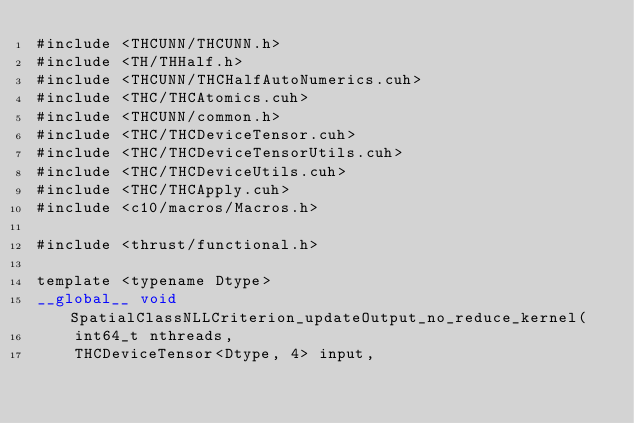Convert code to text. <code><loc_0><loc_0><loc_500><loc_500><_Cuda_>#include <THCUNN/THCUNN.h>
#include <TH/THHalf.h>
#include <THCUNN/THCHalfAutoNumerics.cuh>
#include <THC/THCAtomics.cuh>
#include <THCUNN/common.h>
#include <THC/THCDeviceTensor.cuh>
#include <THC/THCDeviceTensorUtils.cuh>
#include <THC/THCDeviceUtils.cuh>
#include <THC/THCApply.cuh>
#include <c10/macros/Macros.h>

#include <thrust/functional.h>

template <typename Dtype>
__global__ void SpatialClassNLLCriterion_updateOutput_no_reduce_kernel(
    int64_t nthreads,
    THCDeviceTensor<Dtype, 4> input,</code> 